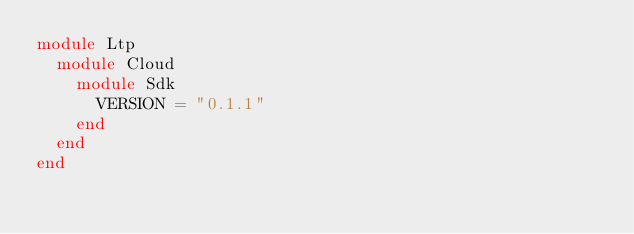<code> <loc_0><loc_0><loc_500><loc_500><_Ruby_>module Ltp
  module Cloud
    module Sdk
      VERSION = "0.1.1"
    end
  end
end
</code> 